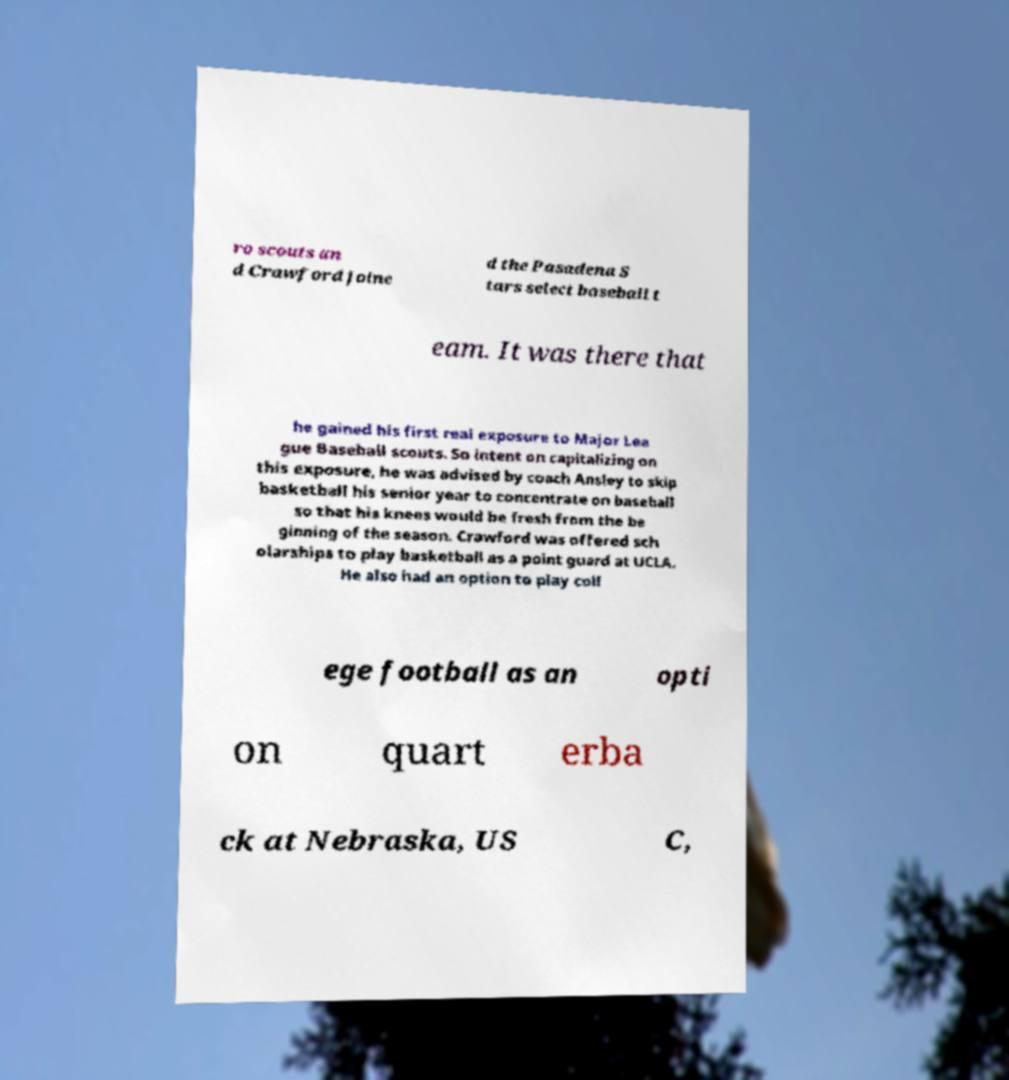Could you assist in decoding the text presented in this image and type it out clearly? ro scouts an d Crawford joine d the Pasadena S tars select baseball t eam. It was there that he gained his first real exposure to Major Lea gue Baseball scouts. So intent on capitalizing on this exposure, he was advised by coach Ansley to skip basketball his senior year to concentrate on baseball so that his knees would be fresh from the be ginning of the season. Crawford was offered sch olarships to play basketball as a point guard at UCLA. He also had an option to play coll ege football as an opti on quart erba ck at Nebraska, US C, 